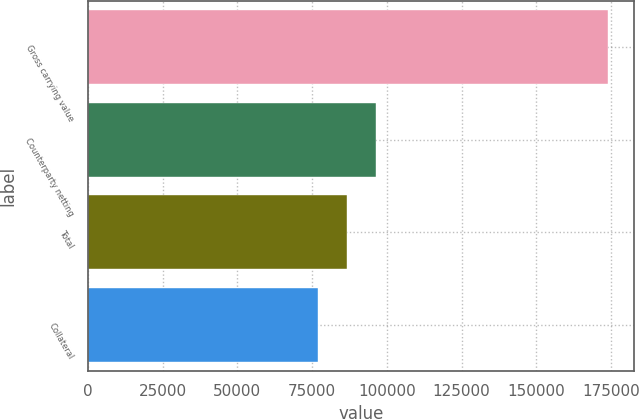<chart> <loc_0><loc_0><loc_500><loc_500><bar_chart><fcel>Gross carrying value<fcel>Counterparty netting<fcel>Total<fcel>Collateral<nl><fcel>173868<fcel>96208<fcel>86500.5<fcel>76793<nl></chart> 